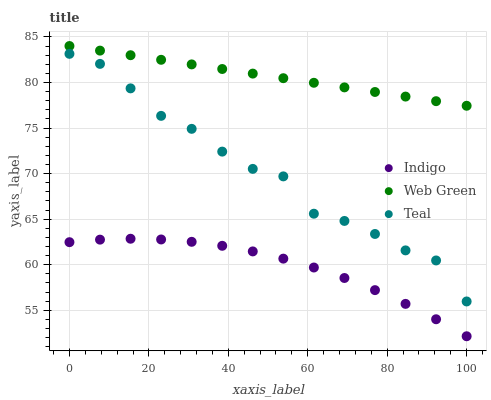Does Indigo have the minimum area under the curve?
Answer yes or no. Yes. Does Web Green have the maximum area under the curve?
Answer yes or no. Yes. Does Teal have the minimum area under the curve?
Answer yes or no. No. Does Teal have the maximum area under the curve?
Answer yes or no. No. Is Web Green the smoothest?
Answer yes or no. Yes. Is Teal the roughest?
Answer yes or no. Yes. Is Teal the smoothest?
Answer yes or no. No. Is Web Green the roughest?
Answer yes or no. No. Does Indigo have the lowest value?
Answer yes or no. Yes. Does Teal have the lowest value?
Answer yes or no. No. Does Web Green have the highest value?
Answer yes or no. Yes. Does Teal have the highest value?
Answer yes or no. No. Is Indigo less than Web Green?
Answer yes or no. Yes. Is Teal greater than Indigo?
Answer yes or no. Yes. Does Indigo intersect Web Green?
Answer yes or no. No. 